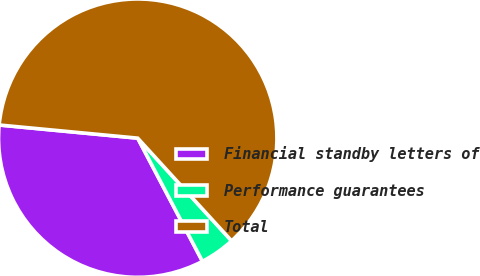Convert chart to OTSL. <chart><loc_0><loc_0><loc_500><loc_500><pie_chart><fcel>Financial standby letters of<fcel>Performance guarantees<fcel>Total<nl><fcel>34.21%<fcel>4.08%<fcel>61.71%<nl></chart> 